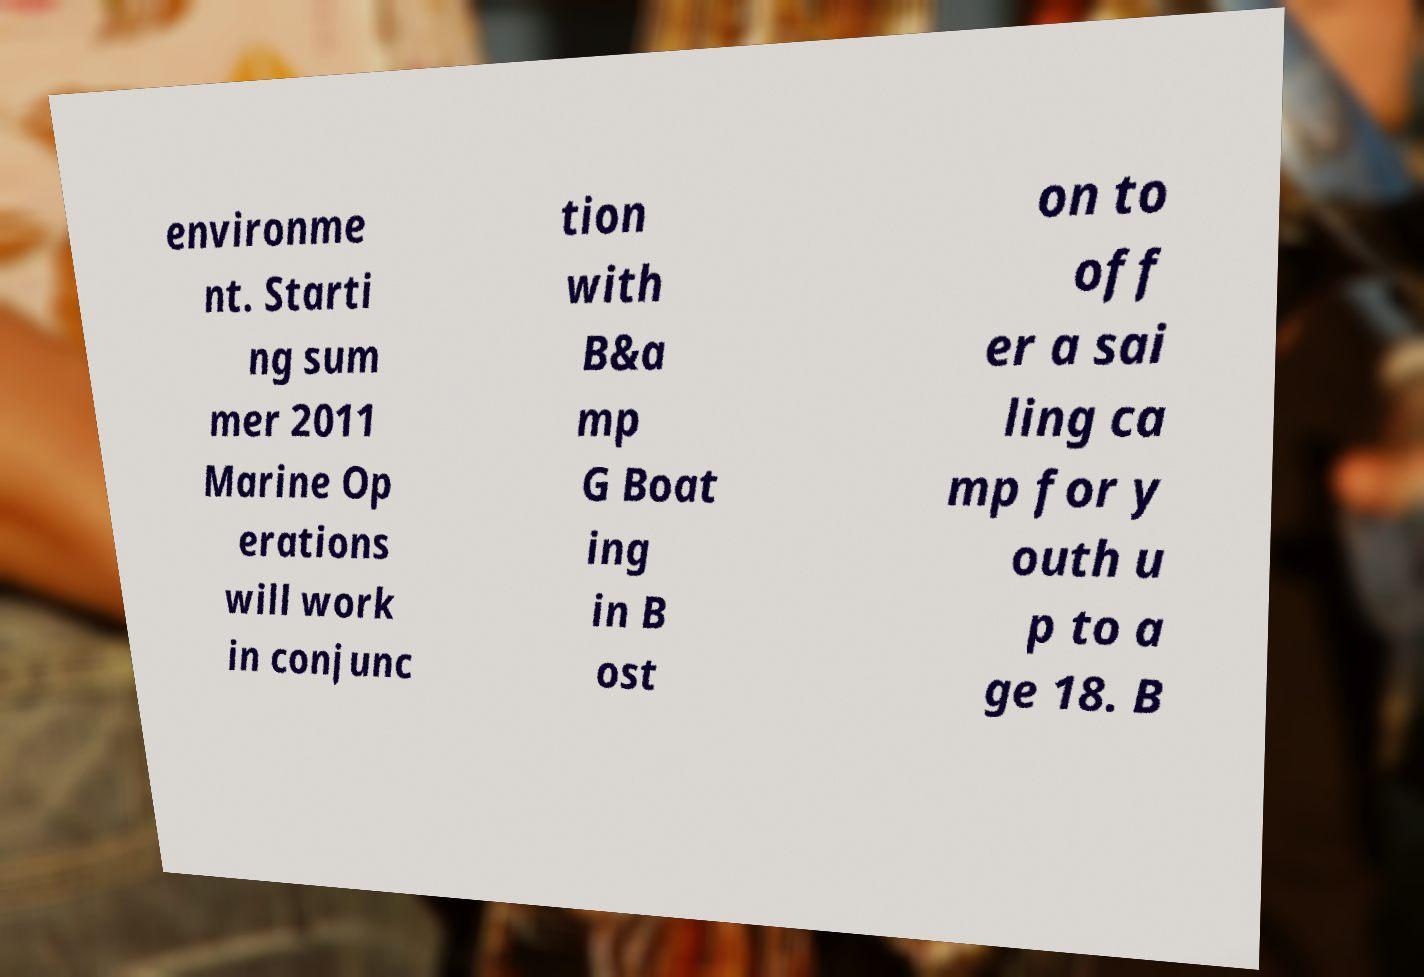Can you accurately transcribe the text from the provided image for me? environme nt. Starti ng sum mer 2011 Marine Op erations will work in conjunc tion with B&a mp G Boat ing in B ost on to off er a sai ling ca mp for y outh u p to a ge 18. B 